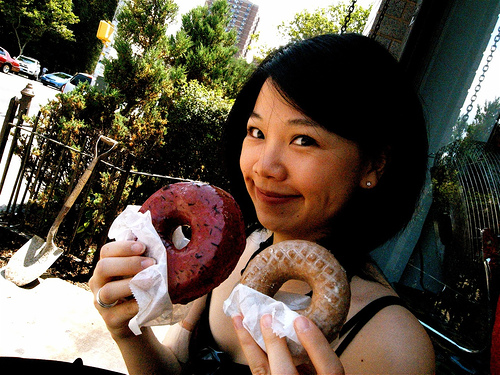How does the person in the image seem to feel about the donuts? The individual is smiling and holding up the donuts to the camera, which conveys a sense of enjoyment and playfulness. The expression suggests she is likely sharing a positive experience or a lighthearted moment involving the donuts. 